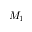Convert formula to latex. <formula><loc_0><loc_0><loc_500><loc_500>M _ { 1 }</formula> 